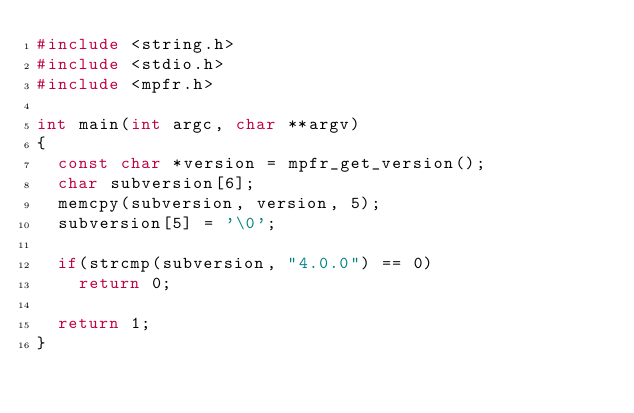Convert code to text. <code><loc_0><loc_0><loc_500><loc_500><_C_>#include <string.h>
#include <stdio.h>
#include <mpfr.h>

int main(int argc, char **argv)
{
  const char *version = mpfr_get_version();
  char subversion[6];
  memcpy(subversion, version, 5);
  subversion[5] = '\0';

  if(strcmp(subversion, "4.0.0") == 0)
    return 0;

  return 1;
}
</code> 